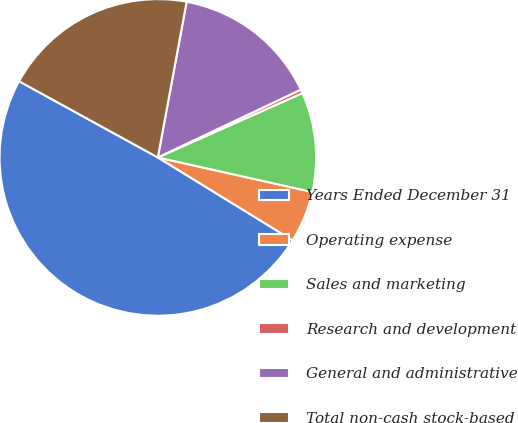Convert chart. <chart><loc_0><loc_0><loc_500><loc_500><pie_chart><fcel>Years Ended December 31<fcel>Operating expense<fcel>Sales and marketing<fcel>Research and development<fcel>General and administrative<fcel>Total non-cash stock-based<nl><fcel>49.22%<fcel>5.27%<fcel>10.16%<fcel>0.39%<fcel>15.04%<fcel>19.92%<nl></chart> 